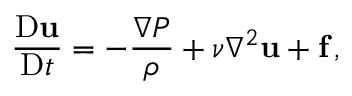Convert formula to latex. <formula><loc_0><loc_0><loc_500><loc_500>\frac { D u } { D t } = - \frac { \nabla P } { \rho } + \nu \nabla ^ { 2 } u + f \, ,</formula> 